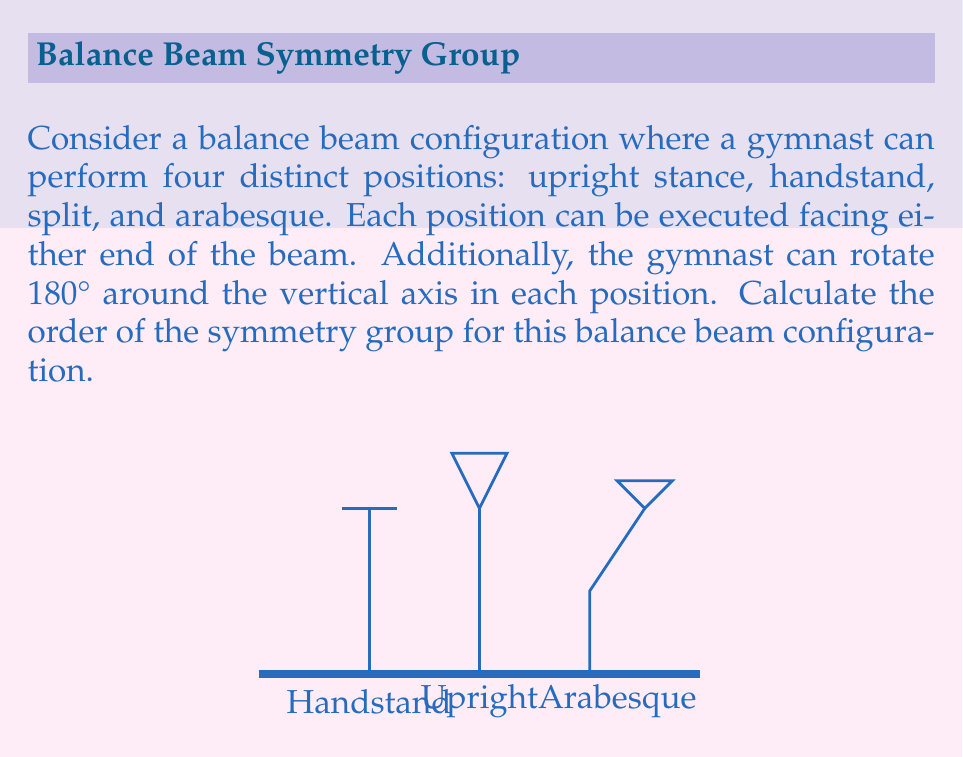Could you help me with this problem? Let's approach this step-by-step:

1) First, we need to identify the elements of the symmetry group:
   - 4 distinct positions: upright stance, handstand, split, arabesque
   - 2 facing directions for each position
   - 2 rotational states (0° and 180°) for each position and direction

2) To calculate the total number of symmetries, we multiply these factors:
   $$ \text{Total symmetries} = 4 \times 2 \times 2 = 16 $$

3) In group theory, the number of elements in a group is called its order. Therefore, the order of this symmetry group is 16.

4) We can represent this group mathematically as:
   $$ G = \{(p, d, r) | p \in P, d \in D, r \in R\} $$
   where:
   $P = \{\text{upright}, \text{handstand}, \text{split}, \text{arabesque}\}$
   $D = \{\text{facing end 1}, \text{facing end 2}\}$
   $R = \{0°, 180°\}$

5) This group is isomorphic to the direct product of three cyclic groups:
   $$ G \cong C_4 \times C_2 \times C_2 $$
   where $C_n$ denotes the cyclic group of order $n$.

6) The order of a direct product of groups is the product of the orders of the individual groups:
   $$ |G| = |C_4| \times |C_2| \times |C_2| = 4 \times 2 \times 2 = 16 $$

Thus, we confirm that the order of the symmetry group is 16.
Answer: 16 